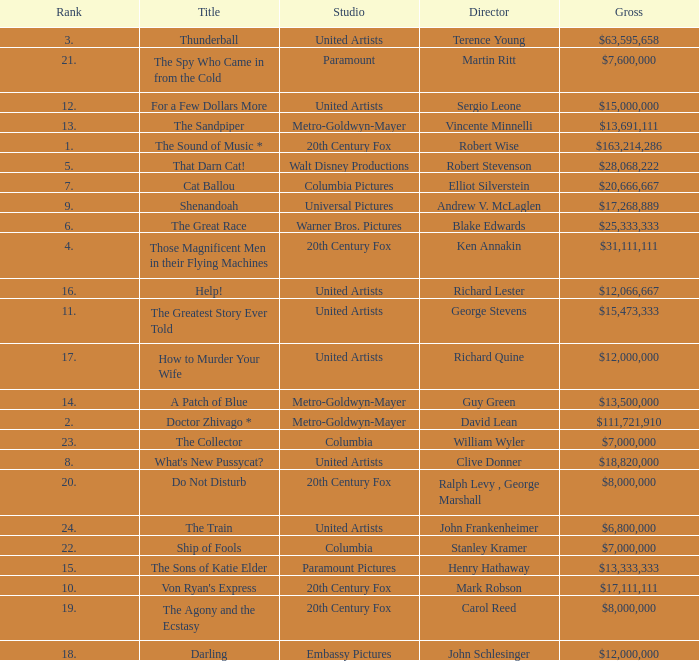What is Studio, when Title is "Do Not Disturb"? 20th Century Fox. 